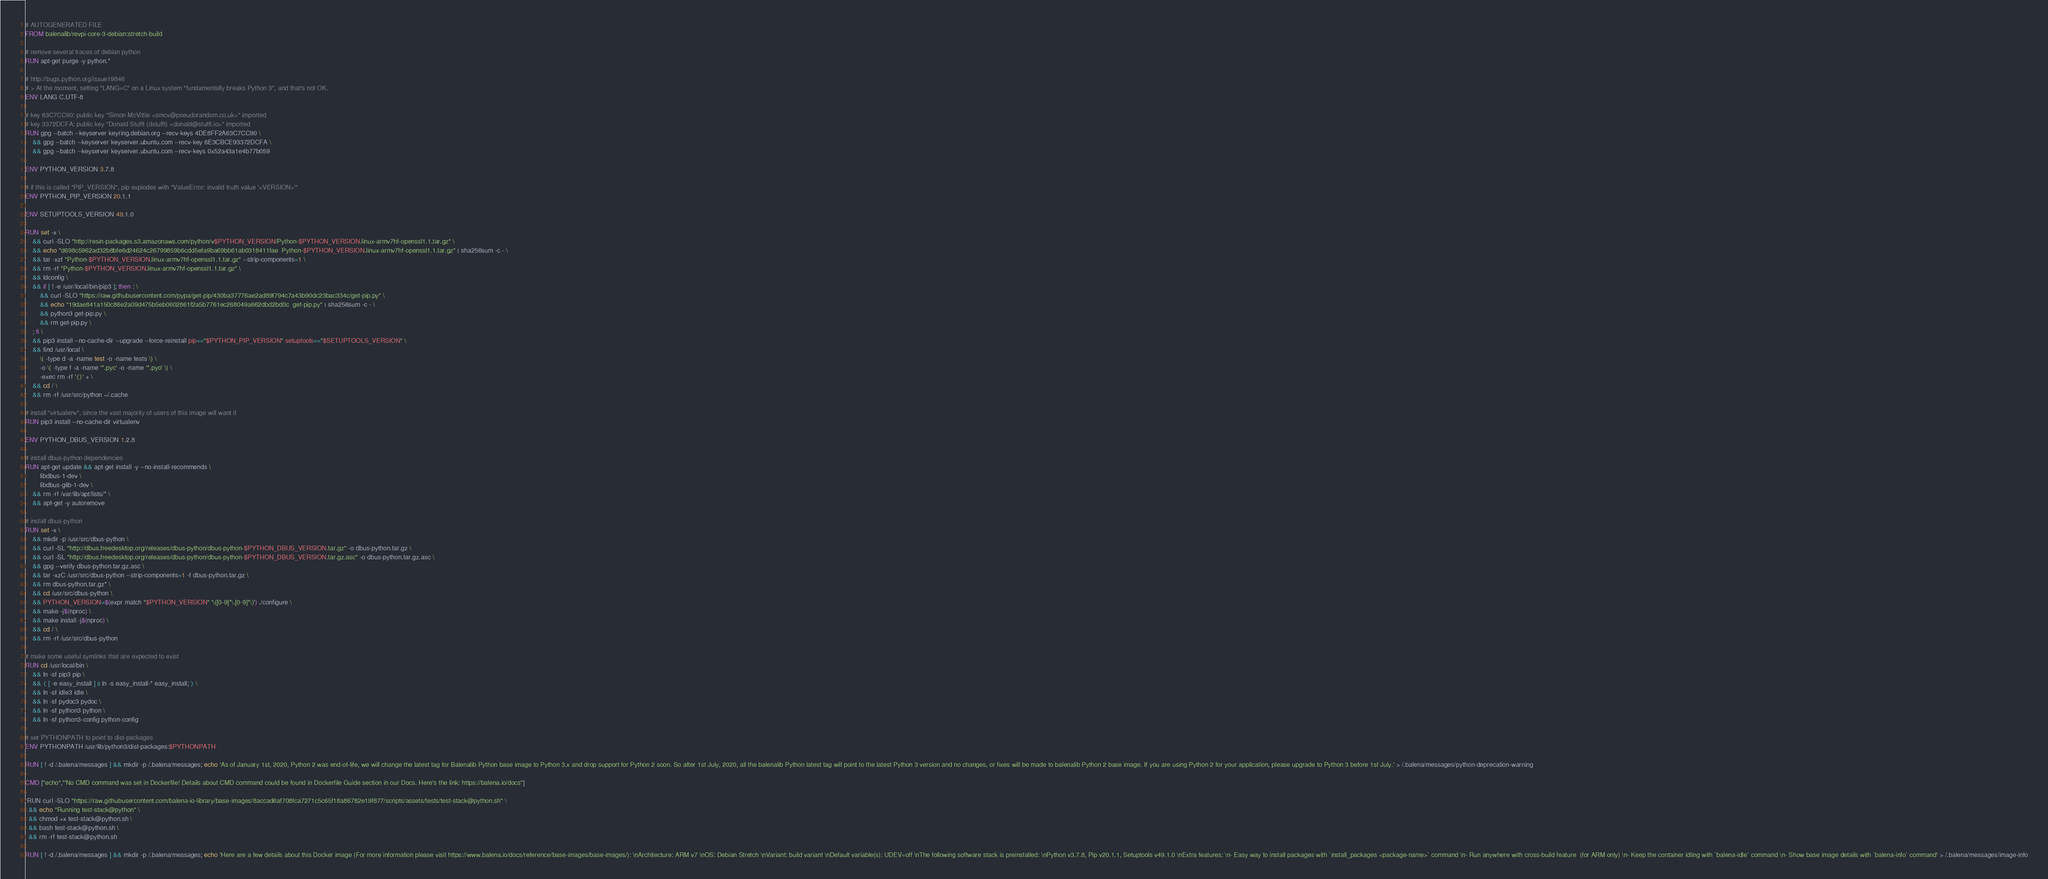Convert code to text. <code><loc_0><loc_0><loc_500><loc_500><_Dockerfile_># AUTOGENERATED FILE
FROM balenalib/revpi-core-3-debian:stretch-build

# remove several traces of debian python
RUN apt-get purge -y python.*

# http://bugs.python.org/issue19846
# > At the moment, setting "LANG=C" on a Linux system *fundamentally breaks Python 3*, and that's not OK.
ENV LANG C.UTF-8

# key 63C7CC90: public key "Simon McVittie <smcv@pseudorandom.co.uk>" imported
# key 3372DCFA: public key "Donald Stufft (dstufft) <donald@stufft.io>" imported
RUN gpg --batch --keyserver keyring.debian.org --recv-keys 4DE8FF2A63C7CC90 \
	&& gpg --batch --keyserver keyserver.ubuntu.com --recv-key 6E3CBCE93372DCFA \
	&& gpg --batch --keyserver keyserver.ubuntu.com --recv-keys 0x52a43a1e4b77b059

ENV PYTHON_VERSION 3.7.8

# if this is called "PIP_VERSION", pip explodes with "ValueError: invalid truth value '<VERSION>'"
ENV PYTHON_PIP_VERSION 20.1.1

ENV SETUPTOOLS_VERSION 49.1.0

RUN set -x \
	&& curl -SLO "http://resin-packages.s3.amazonaws.com/python/v$PYTHON_VERSION/Python-$PYTHON_VERSION.linux-armv7hf-openssl1.1.tar.gz" \
	&& echo "d698c5962ad32b8bfe6d24624c26799859b6cdd5efa9ba69bb61ab0318411fae  Python-$PYTHON_VERSION.linux-armv7hf-openssl1.1.tar.gz" | sha256sum -c - \
	&& tar -xzf "Python-$PYTHON_VERSION.linux-armv7hf-openssl1.1.tar.gz" --strip-components=1 \
	&& rm -rf "Python-$PYTHON_VERSION.linux-armv7hf-openssl1.1.tar.gz" \
	&& ldconfig \
	&& if [ ! -e /usr/local/bin/pip3 ]; then : \
		&& curl -SLO "https://raw.githubusercontent.com/pypa/get-pip/430ba37776ae2ad89f794c7a43b90dc23bac334c/get-pip.py" \
		&& echo "19dae841a150c86e2a09d475b5eb0602861f2a5b7761ec268049a662dbd2bd0c  get-pip.py" | sha256sum -c - \
		&& python3 get-pip.py \
		&& rm get-pip.py \
	; fi \
	&& pip3 install --no-cache-dir --upgrade --force-reinstall pip=="$PYTHON_PIP_VERSION" setuptools=="$SETUPTOOLS_VERSION" \
	&& find /usr/local \
		\( -type d -a -name test -o -name tests \) \
		-o \( -type f -a -name '*.pyc' -o -name '*.pyo' \) \
		-exec rm -rf '{}' + \
	&& cd / \
	&& rm -rf /usr/src/python ~/.cache

# install "virtualenv", since the vast majority of users of this image will want it
RUN pip3 install --no-cache-dir virtualenv

ENV PYTHON_DBUS_VERSION 1.2.8

# install dbus-python dependencies 
RUN apt-get update && apt-get install -y --no-install-recommends \
		libdbus-1-dev \
		libdbus-glib-1-dev \
	&& rm -rf /var/lib/apt/lists/* \
	&& apt-get -y autoremove

# install dbus-python
RUN set -x \
	&& mkdir -p /usr/src/dbus-python \
	&& curl -SL "http://dbus.freedesktop.org/releases/dbus-python/dbus-python-$PYTHON_DBUS_VERSION.tar.gz" -o dbus-python.tar.gz \
	&& curl -SL "http://dbus.freedesktop.org/releases/dbus-python/dbus-python-$PYTHON_DBUS_VERSION.tar.gz.asc" -o dbus-python.tar.gz.asc \
	&& gpg --verify dbus-python.tar.gz.asc \
	&& tar -xzC /usr/src/dbus-python --strip-components=1 -f dbus-python.tar.gz \
	&& rm dbus-python.tar.gz* \
	&& cd /usr/src/dbus-python \
	&& PYTHON_VERSION=$(expr match "$PYTHON_VERSION" '\([0-9]*\.[0-9]*\)') ./configure \
	&& make -j$(nproc) \
	&& make install -j$(nproc) \
	&& cd / \
	&& rm -rf /usr/src/dbus-python

# make some useful symlinks that are expected to exist
RUN cd /usr/local/bin \
	&& ln -sf pip3 pip \
	&& { [ -e easy_install ] || ln -s easy_install-* easy_install; } \
	&& ln -sf idle3 idle \
	&& ln -sf pydoc3 pydoc \
	&& ln -sf python3 python \
	&& ln -sf python3-config python-config

# set PYTHONPATH to point to dist-packages
ENV PYTHONPATH /usr/lib/python3/dist-packages:$PYTHONPATH

RUN [ ! -d /.balena/messages ] && mkdir -p /.balena/messages; echo 'As of January 1st, 2020, Python 2 was end-of-life, we will change the latest tag for Balenalib Python base image to Python 3.x and drop support for Python 2 soon. So after 1st July, 2020, all the balenalib Python latest tag will point to the latest Python 3 version and no changes, or fixes will be made to balenalib Python 2 base image. If you are using Python 2 for your application, please upgrade to Python 3 before 1st July.' > /.balena/messages/python-deprecation-warning

CMD ["echo","'No CMD command was set in Dockerfile! Details about CMD command could be found in Dockerfile Guide section in our Docs. Here's the link: https://balena.io/docs"]

 RUN curl -SLO "https://raw.githubusercontent.com/balena-io-library/base-images/8accad6af708fca7271c5c65f18a86782e19f877/scripts/assets/tests/test-stack@python.sh" \
  && echo "Running test-stack@python" \
  && chmod +x test-stack@python.sh \
  && bash test-stack@python.sh \
  && rm -rf test-stack@python.sh 

RUN [ ! -d /.balena/messages ] && mkdir -p /.balena/messages; echo 'Here are a few details about this Docker image (For more information please visit https://www.balena.io/docs/reference/base-images/base-images/): \nArchitecture: ARM v7 \nOS: Debian Stretch \nVariant: build variant \nDefault variable(s): UDEV=off \nThe following software stack is preinstalled: \nPython v3.7.8, Pip v20.1.1, Setuptools v49.1.0 \nExtra features: \n- Easy way to install packages with `install_packages <package-name>` command \n- Run anywhere with cross-build feature  (for ARM only) \n- Keep the container idling with `balena-idle` command \n- Show base image details with `balena-info` command' > /.balena/messages/image-info
</code> 